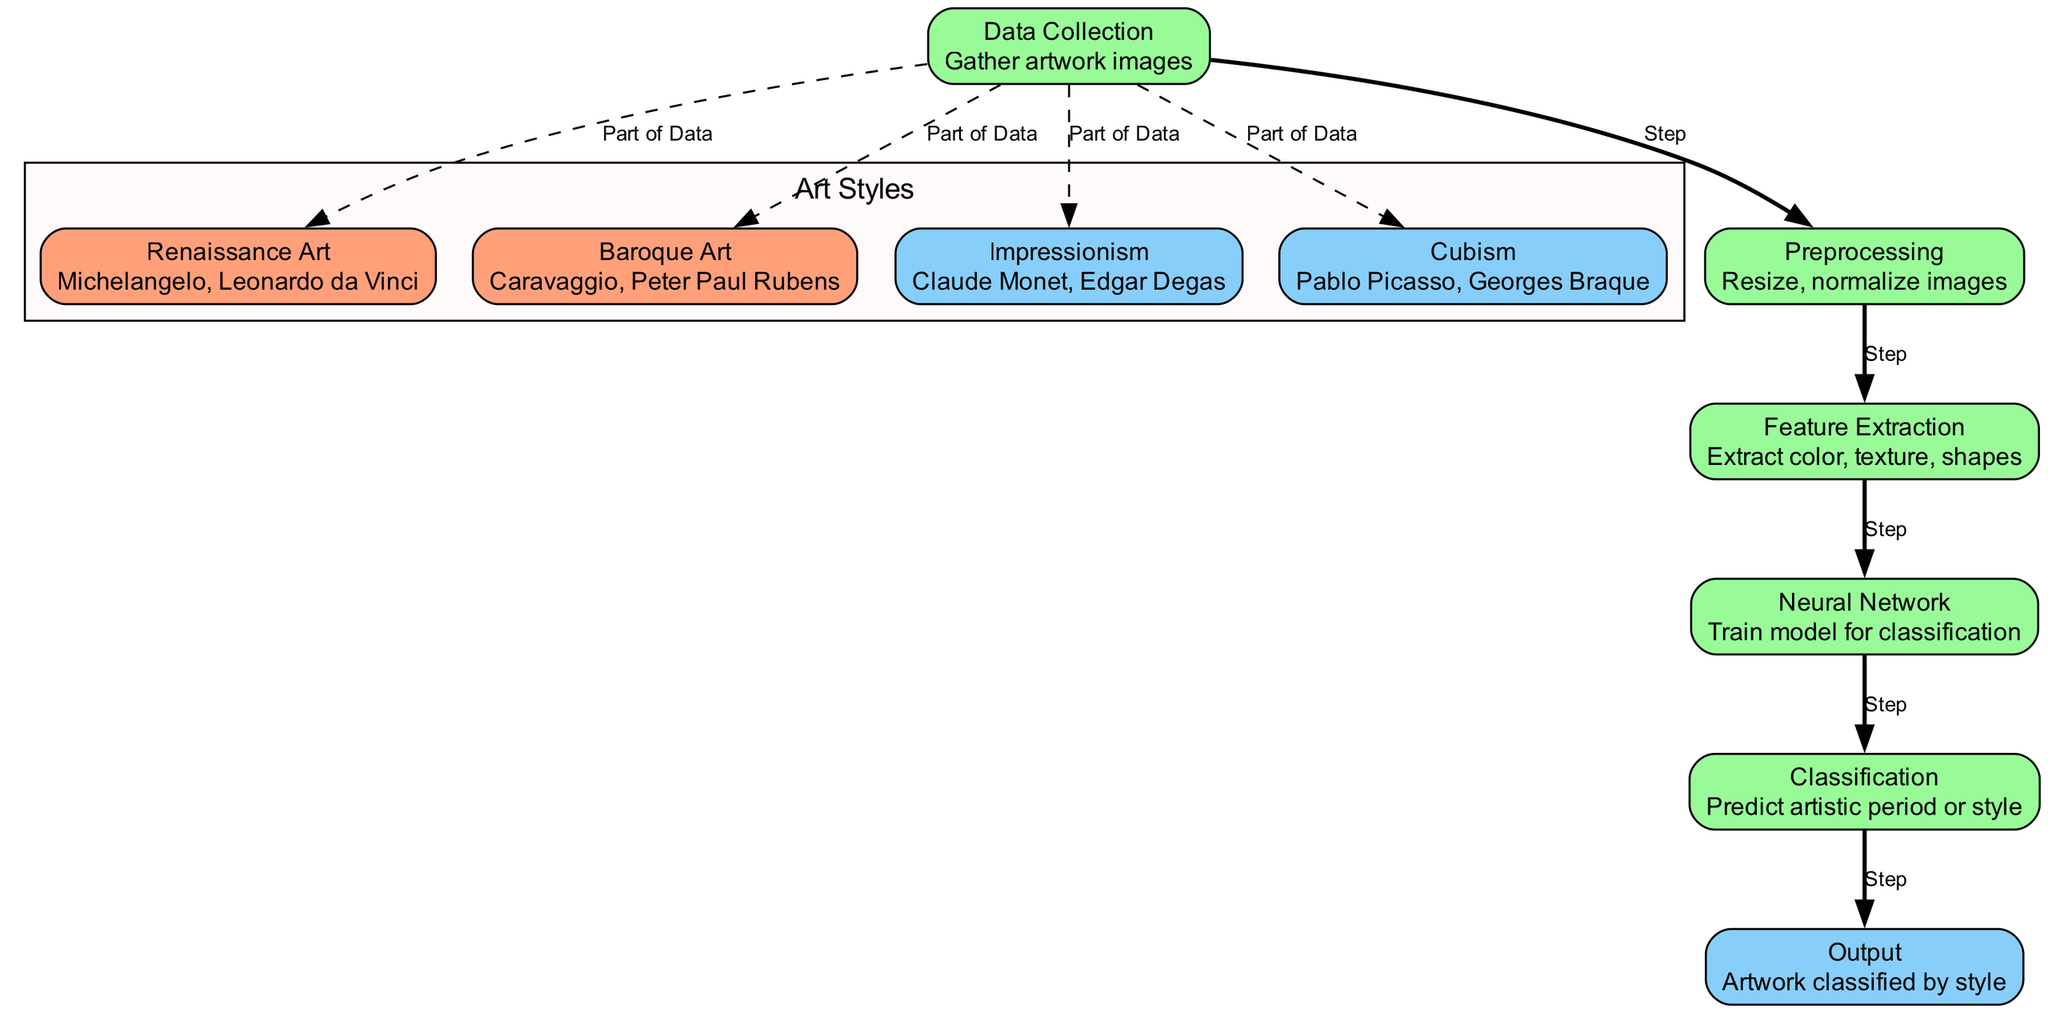What is the first step in the diagram? The diagram starts with the "Data Collection" node, which indicates that gathering artwork images is the initial step.
Answer: Data Collection How many artistic styles are represented in the diagram? There are four artistic styles represented: Renaissance Art, Baroque Art, Impressionism, and Cubism.
Answer: Four Which node comes after "Preprocessing"? After "Preprocessing," the next step is "Feature Extraction."
Answer: Feature Extraction What is extracted during the "Feature Extraction" step? The "Feature Extraction" node indicates that color, texture, and shapes are extracted during this step.
Answer: Color, texture, shapes What is the output of the classification process? The output of the classification process is the artwork classified by style.
Answer: Artwork classified by style What type of relationship exists between "Data Collection" and "Renaissance Art"? The relationship is indicated by a dashed line labeled "Part of Data," showing that Renaissance Art is a part of the data collected.
Answer: Part of Data Which node is responsible for training the model? The "Neural Network" node is responsible for training the model for classification.
Answer: Neural Network What happens after "Classification"? After "Classification," the results are outputted, where the artwork is classified by style.
Answer: Output How many edges connect the data collection node to other nodes? The "Data Collection" node has five edges connecting it to other nodes: four artistic styles and one preprocessing step.
Answer: Five 